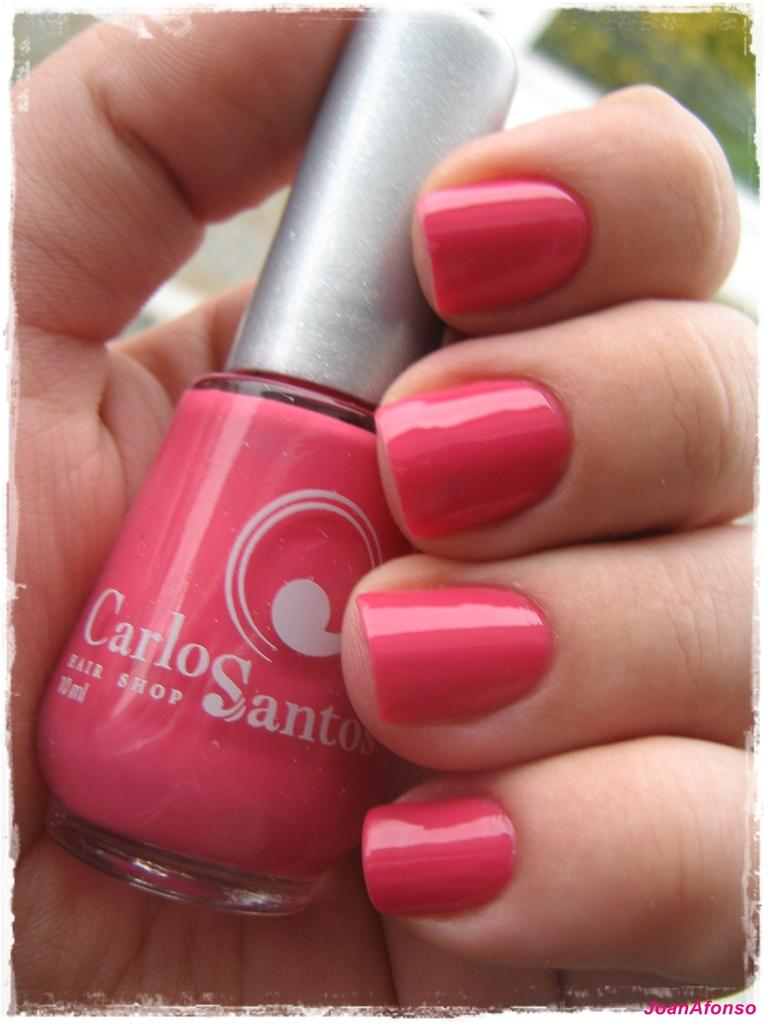What is the main subject of the image? There is a person in the image. What is the person holding in the image? The person is holding a nail polish. What type of shoes is the person wearing in the image? There is no information about shoes in the image, so we cannot determine what type of shoes the person is wearing. 